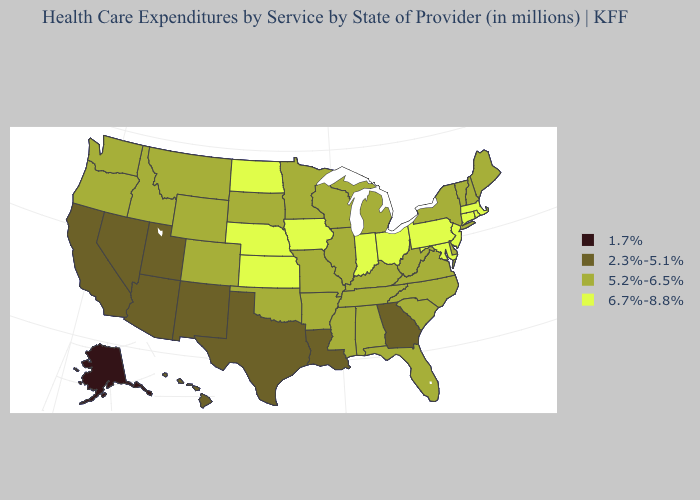Name the states that have a value in the range 1.7%?
Quick response, please. Alaska. What is the highest value in states that border Alabama?
Keep it brief. 5.2%-6.5%. What is the value of Indiana?
Concise answer only. 6.7%-8.8%. Does Hawaii have a higher value than Delaware?
Be succinct. No. What is the value of Connecticut?
Keep it brief. 6.7%-8.8%. What is the value of Michigan?
Keep it brief. 5.2%-6.5%. Name the states that have a value in the range 2.3%-5.1%?
Be succinct. Arizona, California, Georgia, Hawaii, Louisiana, Nevada, New Mexico, Texas, Utah. Among the states that border Pennsylvania , which have the lowest value?
Short answer required. Delaware, New York, West Virginia. Among the states that border Virginia , which have the highest value?
Concise answer only. Maryland. Is the legend a continuous bar?
Write a very short answer. No. Which states have the highest value in the USA?
Write a very short answer. Connecticut, Indiana, Iowa, Kansas, Maryland, Massachusetts, Nebraska, New Jersey, North Dakota, Ohio, Pennsylvania, Rhode Island. What is the value of Montana?
Keep it brief. 5.2%-6.5%. Is the legend a continuous bar?
Be succinct. No. Name the states that have a value in the range 2.3%-5.1%?
Write a very short answer. Arizona, California, Georgia, Hawaii, Louisiana, Nevada, New Mexico, Texas, Utah. Does the map have missing data?
Give a very brief answer. No. 